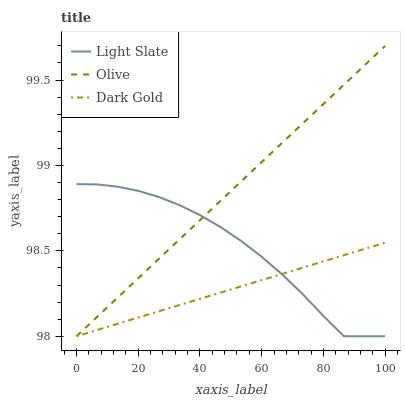Does Dark Gold have the minimum area under the curve?
Answer yes or no. Yes. Does Olive have the maximum area under the curve?
Answer yes or no. Yes. Does Olive have the minimum area under the curve?
Answer yes or no. No. Does Dark Gold have the maximum area under the curve?
Answer yes or no. No. Is Dark Gold the smoothest?
Answer yes or no. Yes. Is Light Slate the roughest?
Answer yes or no. Yes. Is Olive the smoothest?
Answer yes or no. No. Is Olive the roughest?
Answer yes or no. No. Does Light Slate have the lowest value?
Answer yes or no. Yes. Does Olive have the highest value?
Answer yes or no. Yes. Does Dark Gold have the highest value?
Answer yes or no. No. Does Light Slate intersect Olive?
Answer yes or no. Yes. Is Light Slate less than Olive?
Answer yes or no. No. Is Light Slate greater than Olive?
Answer yes or no. No. 